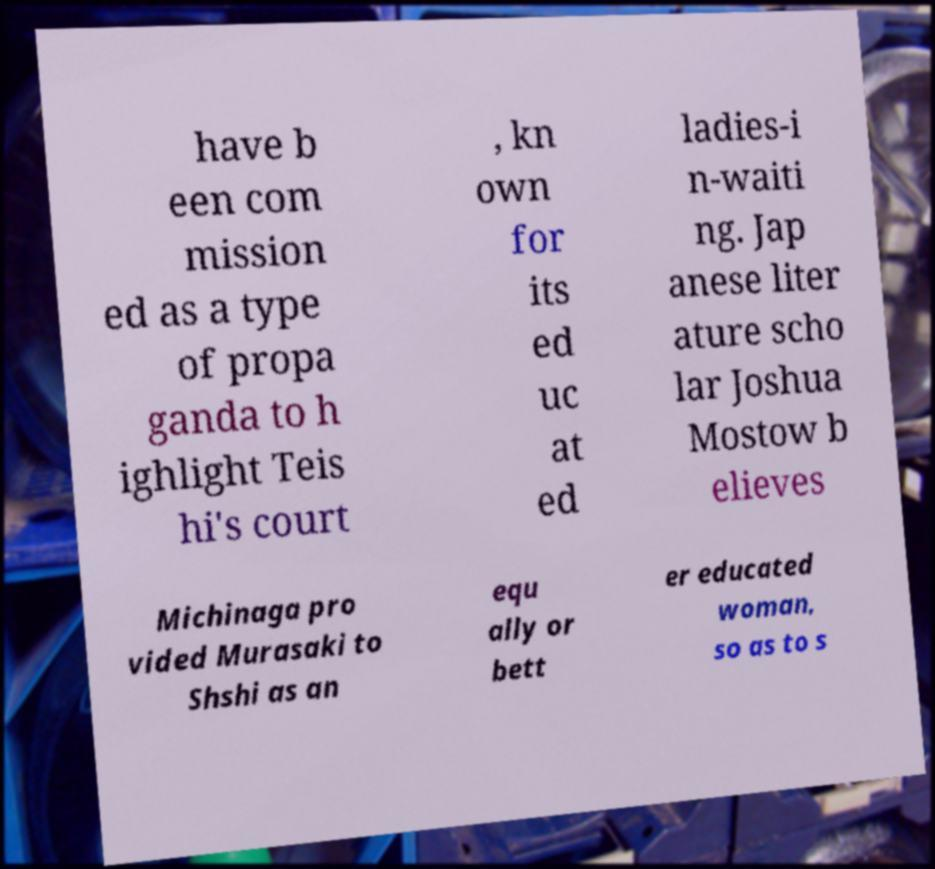Could you assist in decoding the text presented in this image and type it out clearly? have b een com mission ed as a type of propa ganda to h ighlight Teis hi's court , kn own for its ed uc at ed ladies-i n-waiti ng. Jap anese liter ature scho lar Joshua Mostow b elieves Michinaga pro vided Murasaki to Shshi as an equ ally or bett er educated woman, so as to s 